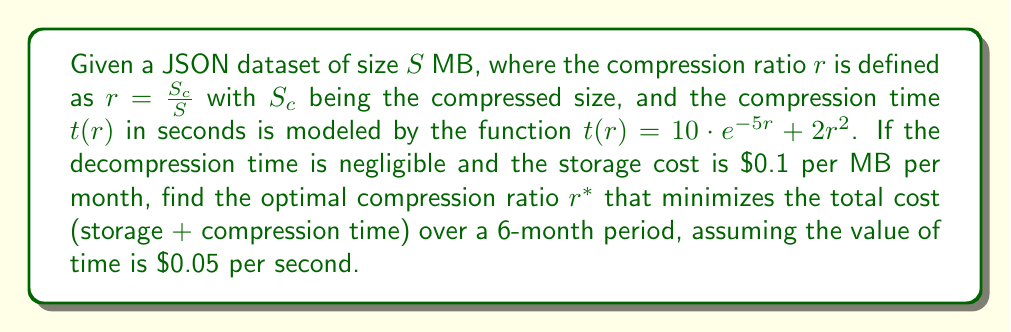Help me with this question. To solve this problem, we need to follow these steps:

1) Define the cost function. The total cost $C(r)$ consists of two parts:
   a) Storage cost: $0.1 \cdot S \cdot r \cdot 6$ ($/MB/month * MB * ratio * 6 months)
   b) Compression time cost: $0.05 \cdot t(r)$ ($/second * seconds)

   So, $C(r) = 0.6Sr + 0.05(10e^{-5r} + 2r^2)$

2) To find the minimum cost, we need to find where the derivative of $C(r)$ equals zero:

   $$\frac{dC}{dr} = 0.6S + 0.05(-50e^{-5r} + 4r) = 0$$

3) Solve this equation:

   $$0.6S - 2.5e^{-5r} + 0.2r = 0$$

4) This is a transcendental equation and cannot be solved algebraically. We need to use numerical methods to find $r^*$.

5) The optimal $r^*$ will depend on the value of $S$. For a typical value of $S = 1000$ MB, we can use a numerical solver to find:

   $$r^* \approx 0.7826$$

6) This means the optimal compression ratio is about 78.26%, or a compression factor of about 1.28.

Note: The actual optimal ratio may vary depending on the specific value of $S$ and any other constraints not mentioned in the problem.
Answer: $r^* \approx 0.7826$ (for $S = 1000$ MB) 